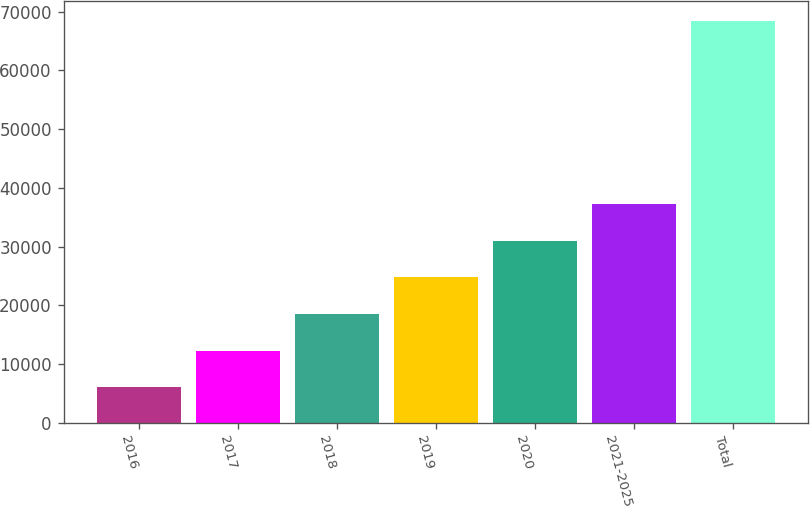<chart> <loc_0><loc_0><loc_500><loc_500><bar_chart><fcel>2016<fcel>2017<fcel>2018<fcel>2019<fcel>2020<fcel>2021-2025<fcel>Total<nl><fcel>6086<fcel>12307.6<fcel>18529.2<fcel>24750.8<fcel>30972.4<fcel>37194<fcel>68302<nl></chart> 